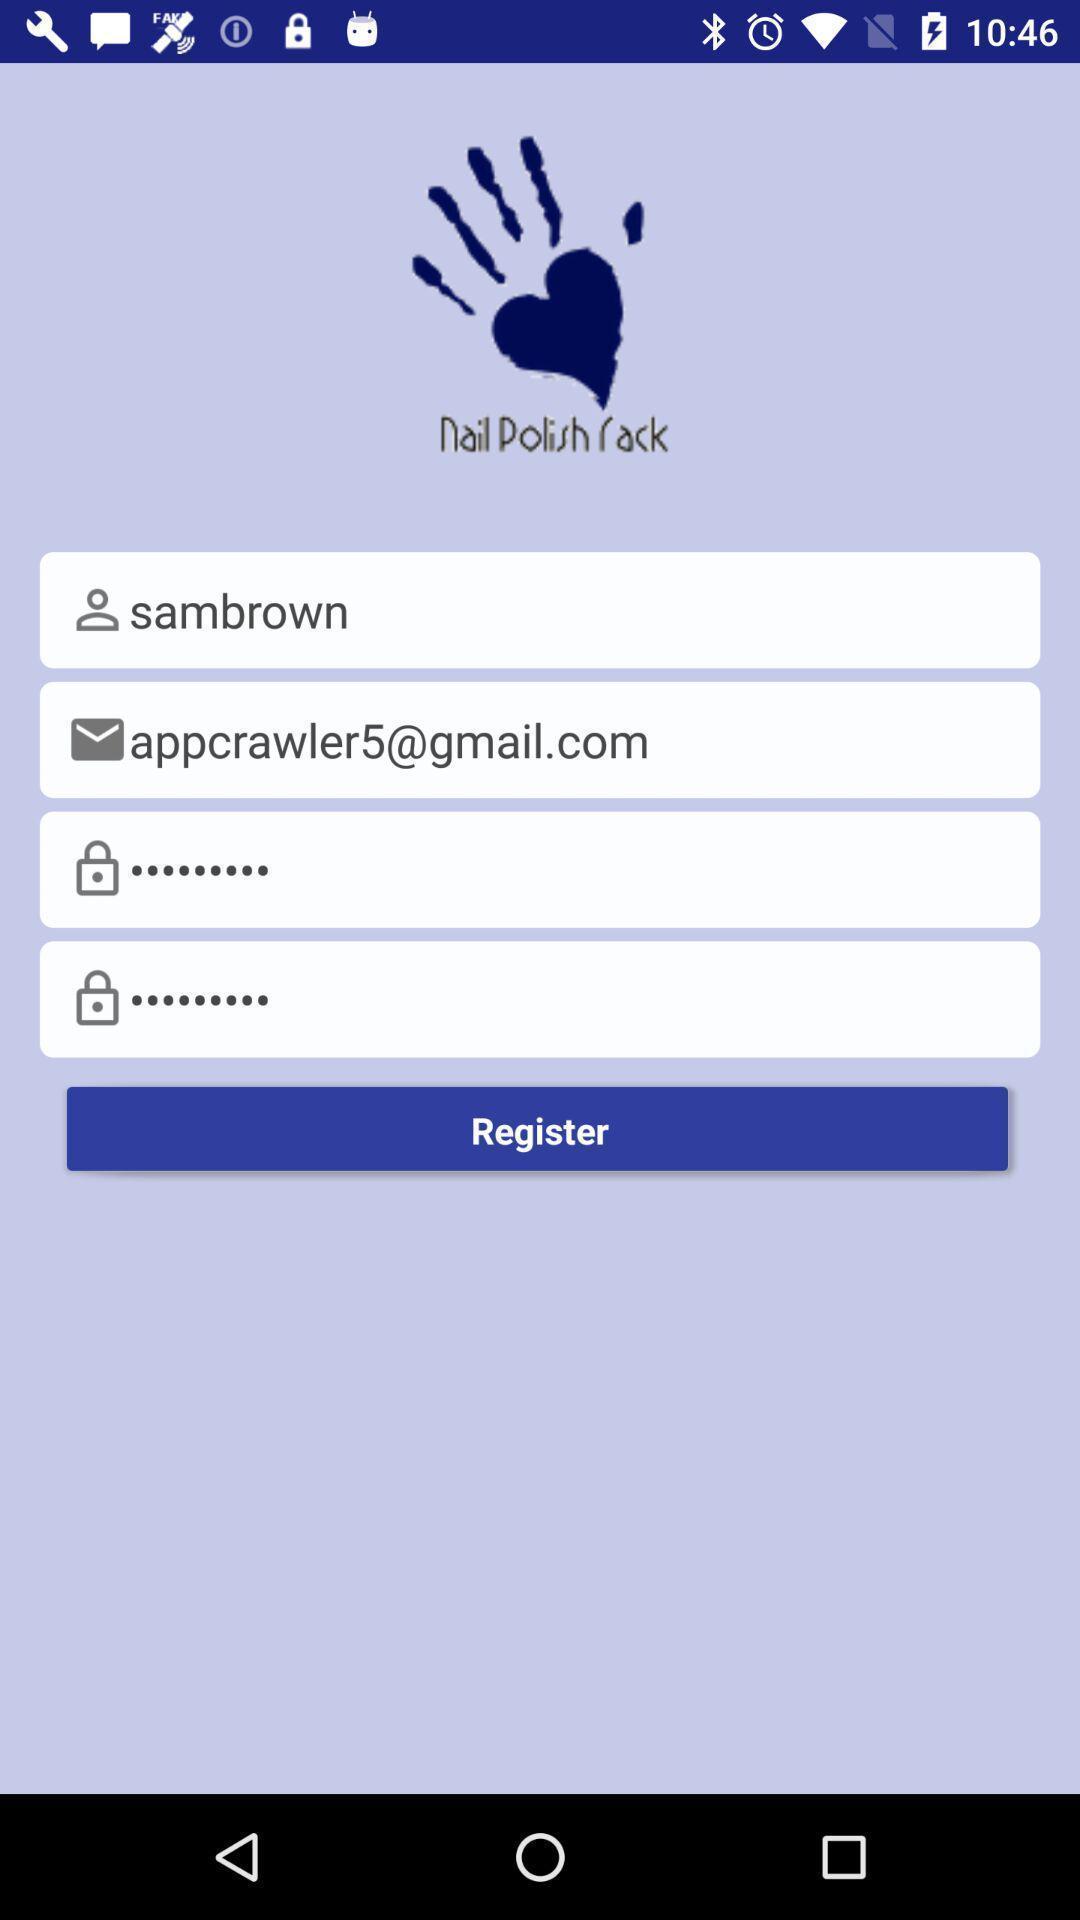Tell me what you see in this picture. Screen shows personal details for a new account. 